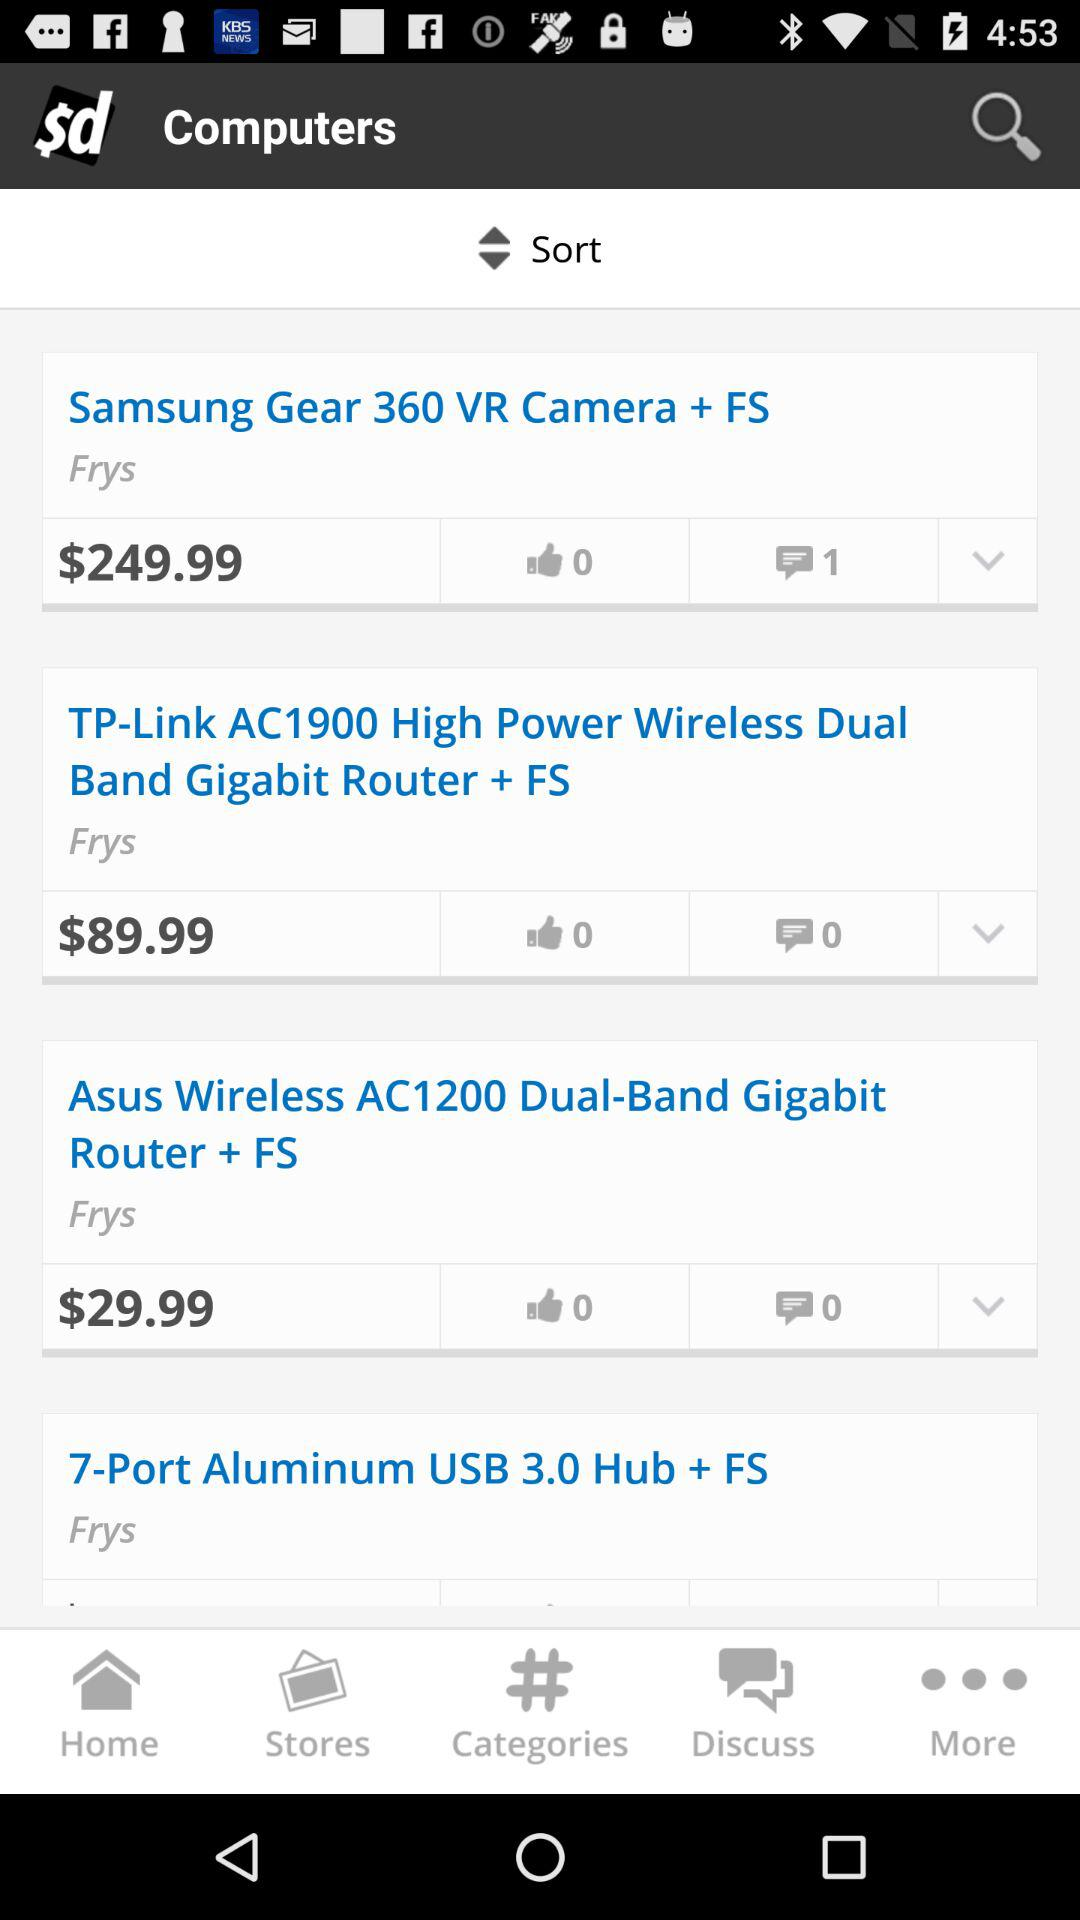How many likes does "Asus Wireless AC1200" have? "Asus Wireless AC1200" has 0 likes. 